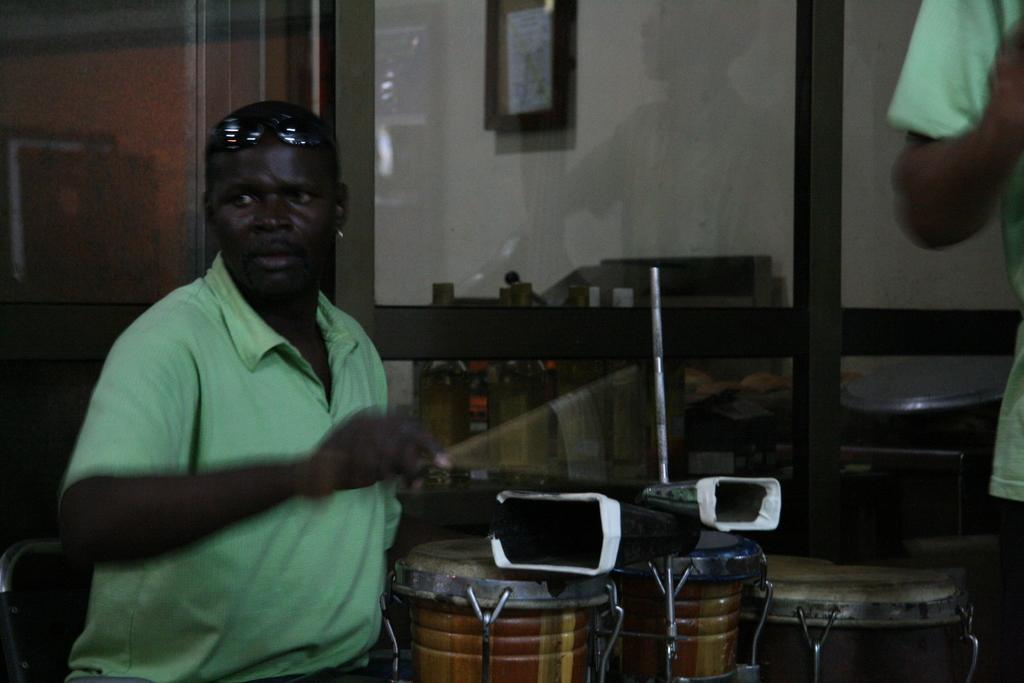What is the main subject of the image? The main subject of the image is a guy. What is the guy wearing in the image? The guy is wearing a green shirt in the image. What can be seen behind the guy in the image? The guy is in front of drums in the image. What type of farm animals can be seen in the image? There are no farm animals present in the image. What flavor of ice cream is the guy holding in the image? The guy is not holding any ice cream in the image. 